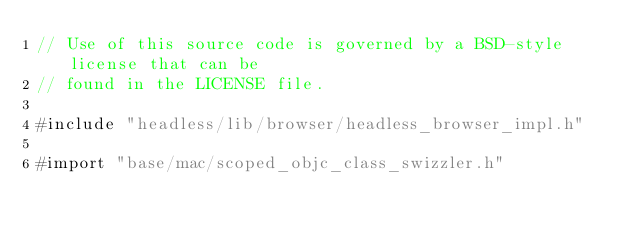<code> <loc_0><loc_0><loc_500><loc_500><_ObjectiveC_>// Use of this source code is governed by a BSD-style license that can be
// found in the LICENSE file.

#include "headless/lib/browser/headless_browser_impl.h"

#import "base/mac/scoped_objc_class_swizzler.h"</code> 